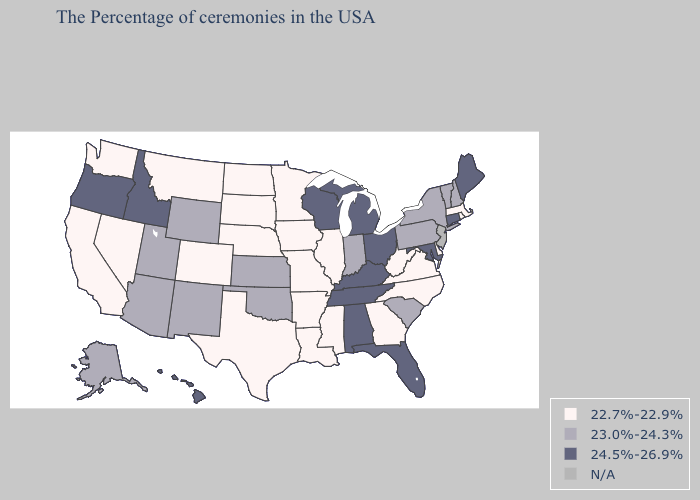Does Kentucky have the lowest value in the USA?
Short answer required. No. Does South Dakota have the highest value in the USA?
Concise answer only. No. Among the states that border Mississippi , which have the highest value?
Keep it brief. Alabama, Tennessee. How many symbols are there in the legend?
Be succinct. 4. Name the states that have a value in the range 23.0%-24.3%?
Be succinct. New Hampshire, Vermont, New York, Pennsylvania, South Carolina, Indiana, Kansas, Oklahoma, Wyoming, New Mexico, Utah, Arizona, Alaska. Name the states that have a value in the range 24.5%-26.9%?
Quick response, please. Maine, Connecticut, Maryland, Ohio, Florida, Michigan, Kentucky, Alabama, Tennessee, Wisconsin, Idaho, Oregon, Hawaii. Which states have the lowest value in the MidWest?
Keep it brief. Illinois, Missouri, Minnesota, Iowa, Nebraska, South Dakota, North Dakota. Which states have the highest value in the USA?
Keep it brief. Maine, Connecticut, Maryland, Ohio, Florida, Michigan, Kentucky, Alabama, Tennessee, Wisconsin, Idaho, Oregon, Hawaii. Name the states that have a value in the range N/A?
Answer briefly. New Jersey. Among the states that border Washington , which have the lowest value?
Keep it brief. Idaho, Oregon. Does Oregon have the highest value in the West?
Be succinct. Yes. What is the value of North Carolina?
Be succinct. 22.7%-22.9%. Name the states that have a value in the range 23.0%-24.3%?
Concise answer only. New Hampshire, Vermont, New York, Pennsylvania, South Carolina, Indiana, Kansas, Oklahoma, Wyoming, New Mexico, Utah, Arizona, Alaska. 